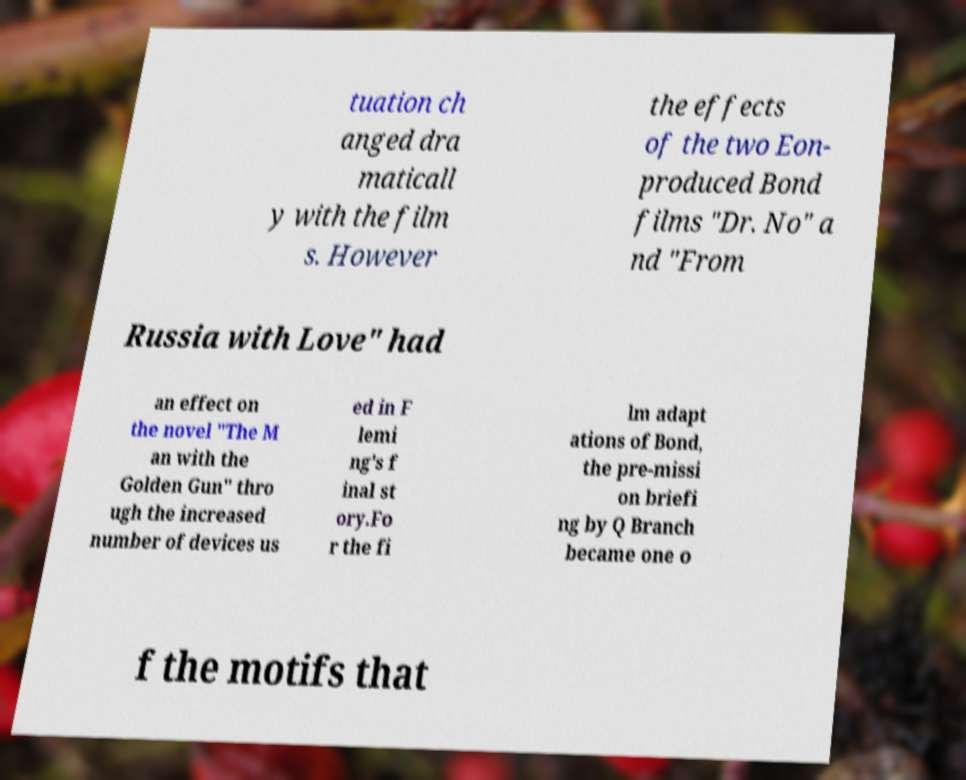Please read and relay the text visible in this image. What does it say? tuation ch anged dra maticall y with the film s. However the effects of the two Eon- produced Bond films "Dr. No" a nd "From Russia with Love" had an effect on the novel "The M an with the Golden Gun" thro ugh the increased number of devices us ed in F lemi ng's f inal st ory.Fo r the fi lm adapt ations of Bond, the pre-missi on briefi ng by Q Branch became one o f the motifs that 